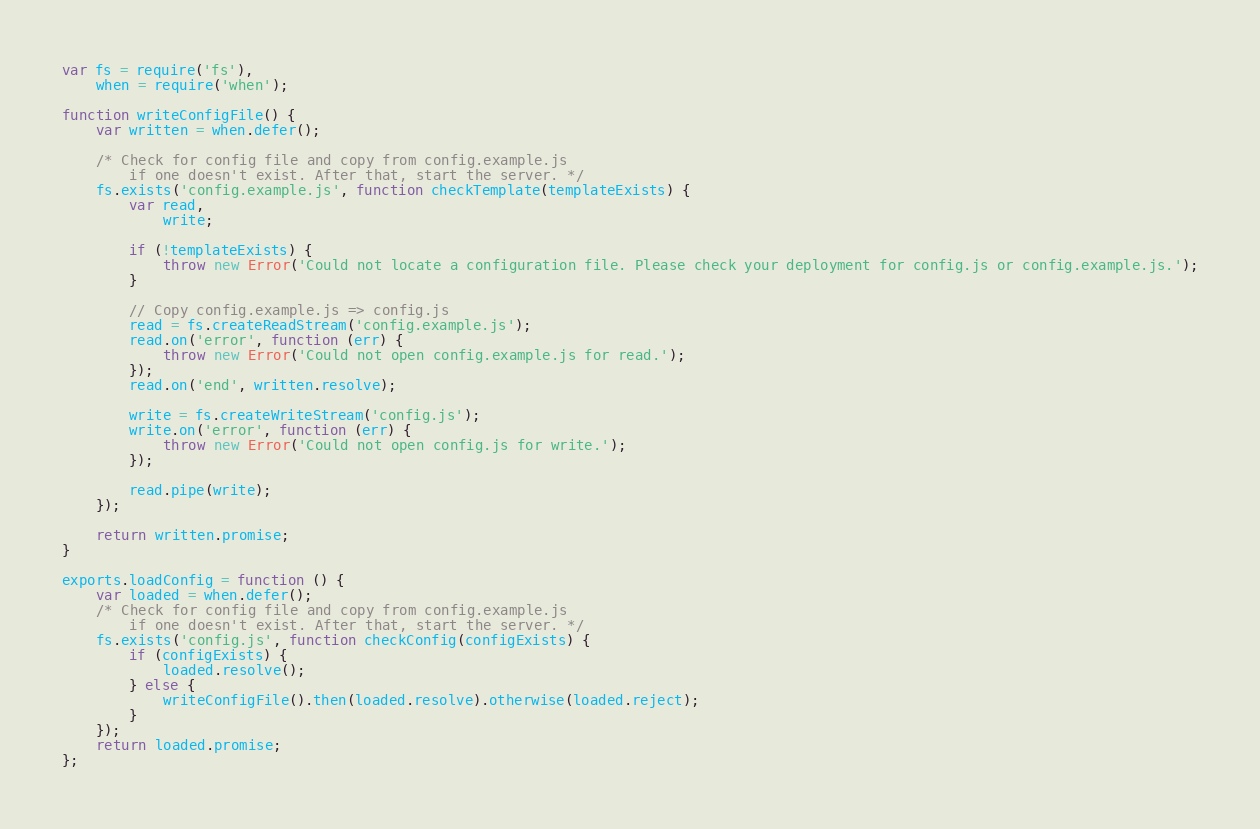Convert code to text. <code><loc_0><loc_0><loc_500><loc_500><_JavaScript_>var fs = require('fs'),
    when = require('when');

function writeConfigFile() {
    var written = when.defer();

    /* Check for config file and copy from config.example.js
        if one doesn't exist. After that, start the server. */
    fs.exists('config.example.js', function checkTemplate(templateExists) {
        var read,
            write;

        if (!templateExists) {
            throw new Error('Could not locate a configuration file. Please check your deployment for config.js or config.example.js.');
        }

        // Copy config.example.js => config.js
        read = fs.createReadStream('config.example.js');
        read.on('error', function (err) {
            throw new Error('Could not open config.example.js for read.');
        });
        read.on('end', written.resolve);

        write = fs.createWriteStream('config.js');
        write.on('error', function (err) {
            throw new Error('Could not open config.js for write.');
        });

        read.pipe(write);
    });

    return written.promise;
}

exports.loadConfig = function () {
    var loaded = when.defer();
    /* Check for config file and copy from config.example.js
        if one doesn't exist. After that, start the server. */
    fs.exists('config.js', function checkConfig(configExists) {
        if (configExists) {
            loaded.resolve();
        } else {
            writeConfigFile().then(loaded.resolve).otherwise(loaded.reject);
        }
    });
    return loaded.promise;
};
</code> 